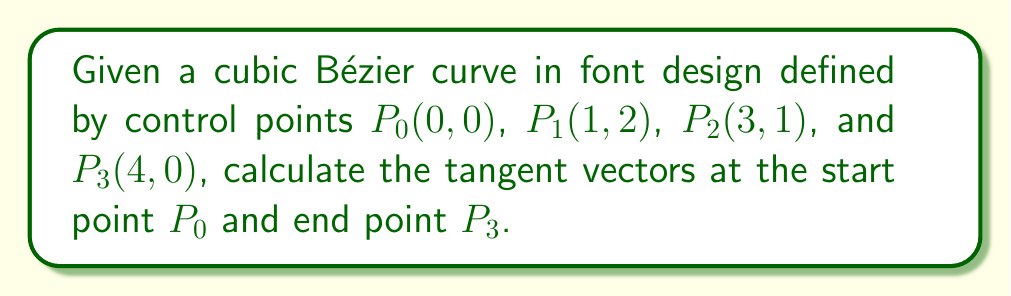Could you help me with this problem? 1. The cubic Bézier curve is defined by the equation:
   $$B(t) = (1-t)^3P_0 + 3t(1-t)^2P_1 + 3t^2(1-t)P_2 + t^3P_3$$
   where $0 \leq t \leq 1$

2. The tangent vector at any point is given by the first derivative of $B(t)$:
   $$B'(t) = 3(1-t)^2(P_1-P_0) + 6t(1-t)(P_2-P_1) + 3t^2(P_3-P_2)$$

3. For the tangent vector at the start point $P_0$, we evaluate $B'(t)$ at $t=0$:
   $$B'(0) = 3(P_1-P_0) = 3((1,2) - (0,0)) = (3,6)$$

4. For the tangent vector at the end point $P_3$, we evaluate $B'(t)$ at $t=1$:
   $$B'(1) = 3(P_3-P_2) = 3((4,0) - (3,1)) = (3,-3)$$

5. Therefore, the tangent vector at $P_0$ is $(3,6)$ and at $P_3$ is $(3,-3)$.

[asy]
unitsize(1cm);
pair P0=(0,0), P1=(1,2), P2=(3,1), P3=(4,0);
draw(P0..controls P1 and P2..P3, blue);
dot(P0^^P1^^P2^^P3);
label("$P_0$", P0, SW);
label("$P_1$", P1, NE);
label("$P_2$", P2, N);
label("$P_3$", P3, SE);
draw(P0--P0+(3,6), red, arrow=Arrow(TeXHead));
draw(P3--P3+(3,-3), red, arrow=Arrow(TeXHead));
label("$(3,6)$", P0+(1.5,3), NE, red);
label("$(3,-3)$", P3+(1.5,-1.5), SE, red);
[/asy]
Answer: Tangent vectors: $(3,6)$ at $P_0$, $(3,-3)$ at $P_3$ 